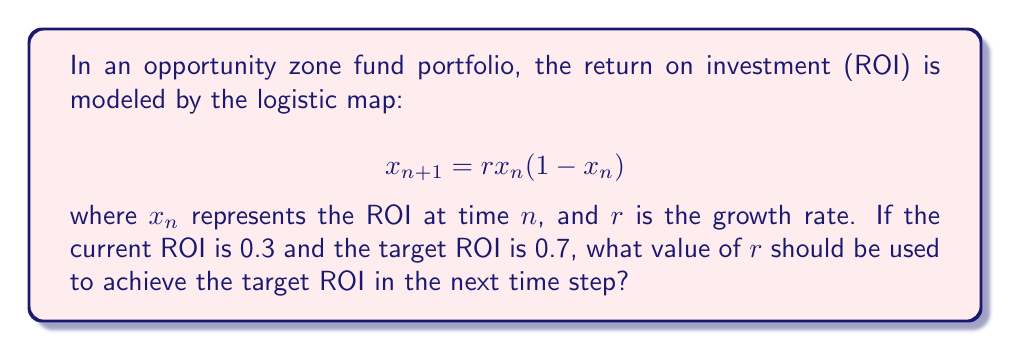Solve this math problem. To solve this problem, we need to use the logistic map equation and work backwards to find the appropriate value of $r$. Let's follow these steps:

1. We know that:
   $x_n = 0.3$ (current ROI)
   $x_{n+1} = 0.7$ (target ROI)

2. Substitute these values into the logistic map equation:
   $$0.7 = r(0.3)(1-0.3)$$

3. Simplify the right side of the equation:
   $$0.7 = r(0.3)(0.7) = 0.21r$$

4. Solve for $r$:
   $$r = \frac{0.7}{0.21} = \frac{10}{3}$$

5. Simplify the fraction:
   $$r = 3.3333...$$

Therefore, to achieve the target ROI of 0.7 in the next time step from the current ROI of 0.3, the growth rate $r$ should be set to approximately 3.3333.

This value of $r$ demonstrates how chaos control techniques can be applied to optimize portfolio management in opportunity zone funds. By carefully selecting the growth rate, we can guide the system towards a desired outcome, even in a chaotic system like financial markets.
Answer: $r = \frac{10}{3} \approx 3.3333$ 